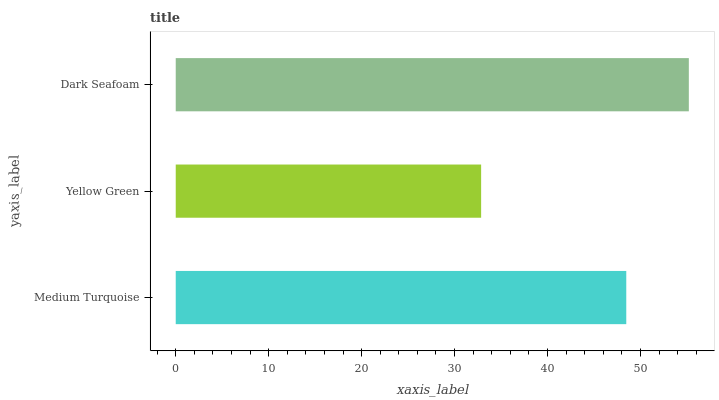Is Yellow Green the minimum?
Answer yes or no. Yes. Is Dark Seafoam the maximum?
Answer yes or no. Yes. Is Dark Seafoam the minimum?
Answer yes or no. No. Is Yellow Green the maximum?
Answer yes or no. No. Is Dark Seafoam greater than Yellow Green?
Answer yes or no. Yes. Is Yellow Green less than Dark Seafoam?
Answer yes or no. Yes. Is Yellow Green greater than Dark Seafoam?
Answer yes or no. No. Is Dark Seafoam less than Yellow Green?
Answer yes or no. No. Is Medium Turquoise the high median?
Answer yes or no. Yes. Is Medium Turquoise the low median?
Answer yes or no. Yes. Is Yellow Green the high median?
Answer yes or no. No. Is Dark Seafoam the low median?
Answer yes or no. No. 